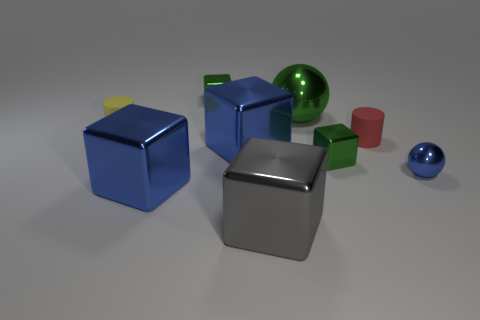Subtract all tiny cubes. How many cubes are left? 3 Subtract all cyan cylinders. How many blue blocks are left? 2 Subtract 1 cubes. How many cubes are left? 4 Subtract all gray blocks. How many blocks are left? 4 Add 1 gray objects. How many objects exist? 10 Subtract all cylinders. How many objects are left? 7 Subtract all yellow cubes. Subtract all yellow cylinders. How many cubes are left? 5 Add 7 green metal objects. How many green metal objects exist? 10 Subtract 1 green spheres. How many objects are left? 8 Subtract all small blue things. Subtract all green cubes. How many objects are left? 6 